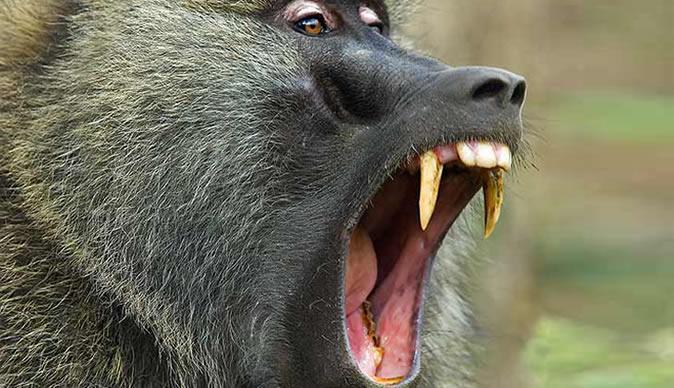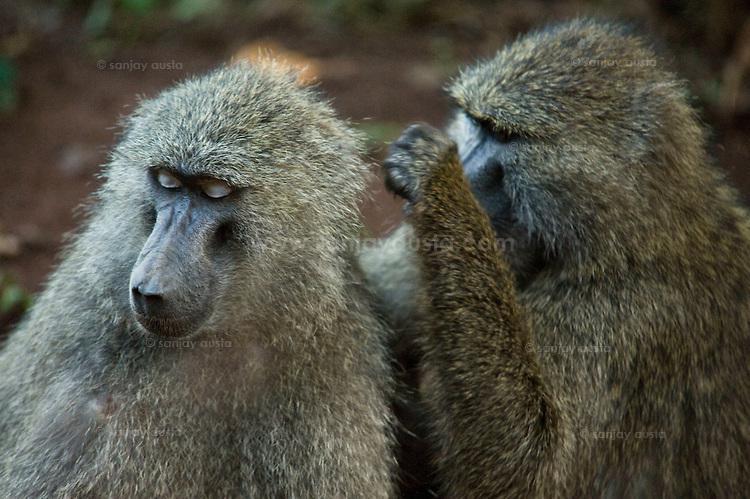The first image is the image on the left, the second image is the image on the right. For the images shown, is this caption "The right image contains exactly two primates." true? Answer yes or no. Yes. 